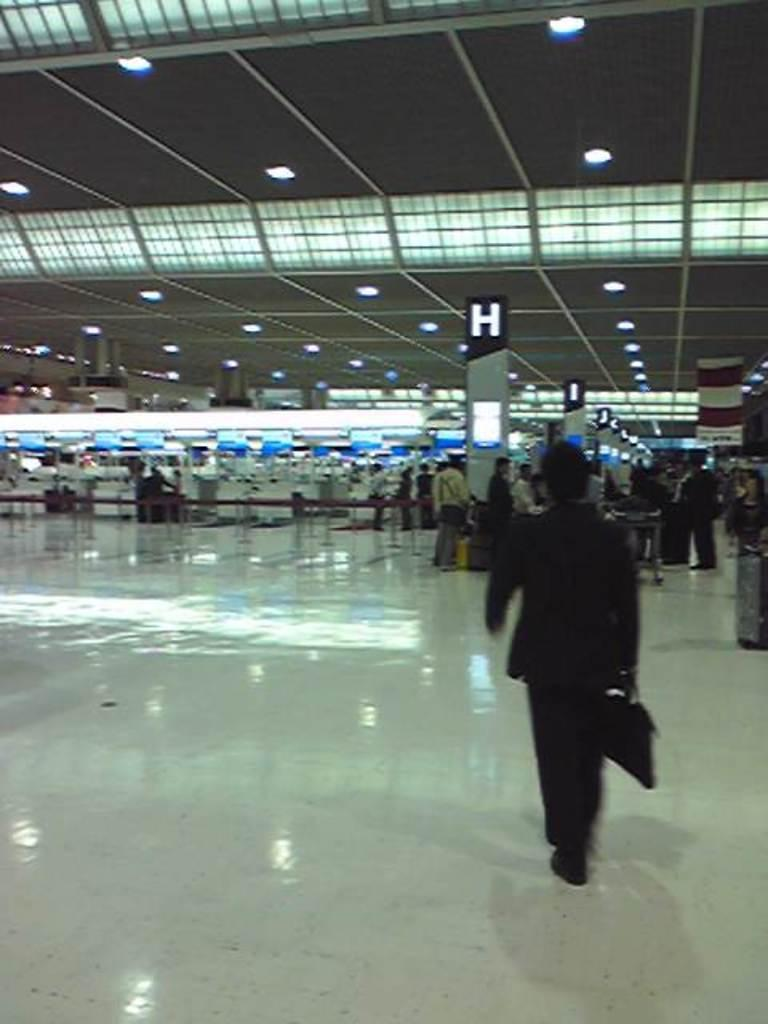What can be seen in the image? There are people standing in the image. Where are the people standing? The people are standing on the floor. What can be seen in the background of the image? There are pillars and lights on the ceiling in the background of the image. What type of location is depicted in the image? The image is an inside view of a building. How many cats can be seen playing with a beast in the image? There are no cats or beasts present in the image; it features people standing in a building. Is there a fire visible in the image? There is no fire visible in the image; it shows people standing in a building with pillars and lights on the ceiling. 